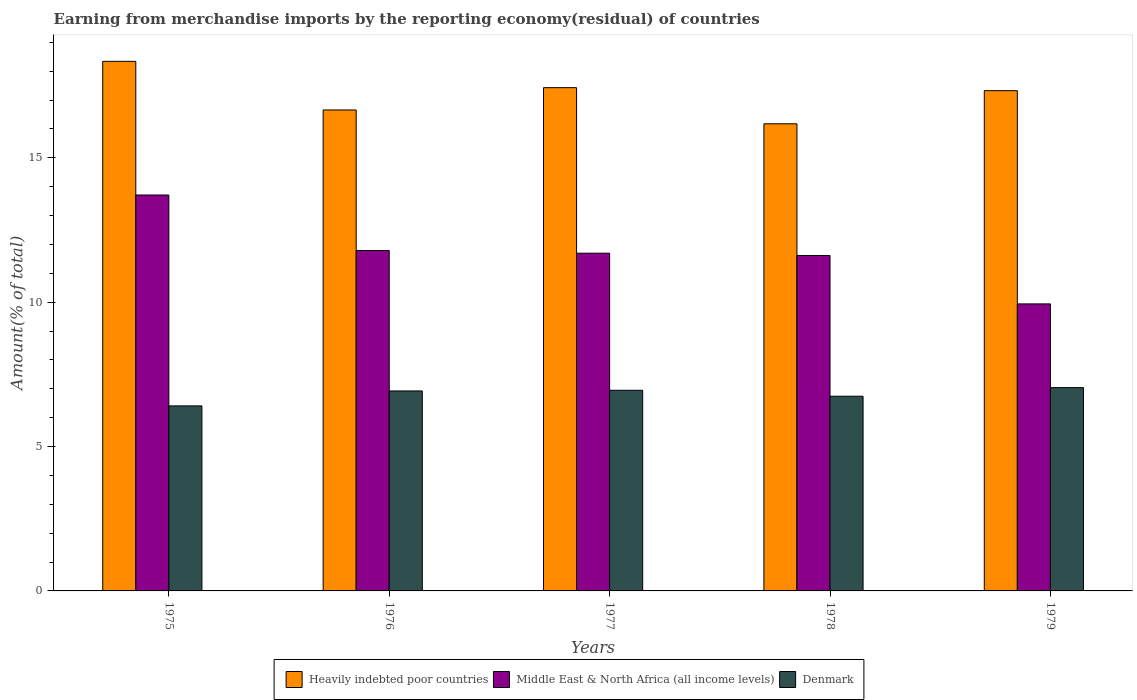How many different coloured bars are there?
Offer a very short reply. 3. How many groups of bars are there?
Ensure brevity in your answer.  5. How many bars are there on the 4th tick from the right?
Your answer should be compact. 3. What is the label of the 1st group of bars from the left?
Provide a short and direct response. 1975. What is the percentage of amount earned from merchandise imports in Middle East & North Africa (all income levels) in 1976?
Offer a very short reply. 11.79. Across all years, what is the maximum percentage of amount earned from merchandise imports in Heavily indebted poor countries?
Provide a succinct answer. 18.34. Across all years, what is the minimum percentage of amount earned from merchandise imports in Middle East & North Africa (all income levels)?
Your response must be concise. 9.94. In which year was the percentage of amount earned from merchandise imports in Heavily indebted poor countries maximum?
Ensure brevity in your answer.  1975. In which year was the percentage of amount earned from merchandise imports in Heavily indebted poor countries minimum?
Your answer should be very brief. 1978. What is the total percentage of amount earned from merchandise imports in Heavily indebted poor countries in the graph?
Ensure brevity in your answer.  85.93. What is the difference between the percentage of amount earned from merchandise imports in Middle East & North Africa (all income levels) in 1975 and that in 1977?
Offer a terse response. 2.02. What is the difference between the percentage of amount earned from merchandise imports in Heavily indebted poor countries in 1977 and the percentage of amount earned from merchandise imports in Middle East & North Africa (all income levels) in 1976?
Offer a terse response. 5.64. What is the average percentage of amount earned from merchandise imports in Middle East & North Africa (all income levels) per year?
Offer a very short reply. 11.75. In the year 1979, what is the difference between the percentage of amount earned from merchandise imports in Middle East & North Africa (all income levels) and percentage of amount earned from merchandise imports in Denmark?
Provide a succinct answer. 2.9. In how many years, is the percentage of amount earned from merchandise imports in Heavily indebted poor countries greater than 7 %?
Ensure brevity in your answer.  5. What is the ratio of the percentage of amount earned from merchandise imports in Denmark in 1975 to that in 1977?
Your answer should be very brief. 0.92. What is the difference between the highest and the second highest percentage of amount earned from merchandise imports in Heavily indebted poor countries?
Offer a very short reply. 0.91. What is the difference between the highest and the lowest percentage of amount earned from merchandise imports in Middle East & North Africa (all income levels)?
Ensure brevity in your answer.  3.77. Is the sum of the percentage of amount earned from merchandise imports in Denmark in 1977 and 1978 greater than the maximum percentage of amount earned from merchandise imports in Heavily indebted poor countries across all years?
Provide a succinct answer. No. What does the 1st bar from the left in 1979 represents?
Provide a succinct answer. Heavily indebted poor countries. What does the 3rd bar from the right in 1976 represents?
Make the answer very short. Heavily indebted poor countries. How many years are there in the graph?
Provide a short and direct response. 5. Where does the legend appear in the graph?
Your answer should be compact. Bottom center. What is the title of the graph?
Offer a terse response. Earning from merchandise imports by the reporting economy(residual) of countries. Does "Lao PDR" appear as one of the legend labels in the graph?
Your answer should be very brief. No. What is the label or title of the X-axis?
Provide a succinct answer. Years. What is the label or title of the Y-axis?
Keep it short and to the point. Amount(% of total). What is the Amount(% of total) in Heavily indebted poor countries in 1975?
Give a very brief answer. 18.34. What is the Amount(% of total) in Middle East & North Africa (all income levels) in 1975?
Keep it short and to the point. 13.71. What is the Amount(% of total) of Denmark in 1975?
Your answer should be very brief. 6.41. What is the Amount(% of total) of Heavily indebted poor countries in 1976?
Your response must be concise. 16.66. What is the Amount(% of total) in Middle East & North Africa (all income levels) in 1976?
Give a very brief answer. 11.79. What is the Amount(% of total) in Denmark in 1976?
Provide a short and direct response. 6.93. What is the Amount(% of total) of Heavily indebted poor countries in 1977?
Provide a succinct answer. 17.43. What is the Amount(% of total) of Middle East & North Africa (all income levels) in 1977?
Offer a very short reply. 11.7. What is the Amount(% of total) in Denmark in 1977?
Your response must be concise. 6.95. What is the Amount(% of total) of Heavily indebted poor countries in 1978?
Your answer should be very brief. 16.18. What is the Amount(% of total) of Middle East & North Africa (all income levels) in 1978?
Your response must be concise. 11.62. What is the Amount(% of total) in Denmark in 1978?
Provide a short and direct response. 6.74. What is the Amount(% of total) in Heavily indebted poor countries in 1979?
Provide a short and direct response. 17.33. What is the Amount(% of total) in Middle East & North Africa (all income levels) in 1979?
Give a very brief answer. 9.94. What is the Amount(% of total) in Denmark in 1979?
Provide a succinct answer. 7.04. Across all years, what is the maximum Amount(% of total) of Heavily indebted poor countries?
Your response must be concise. 18.34. Across all years, what is the maximum Amount(% of total) in Middle East & North Africa (all income levels)?
Provide a succinct answer. 13.71. Across all years, what is the maximum Amount(% of total) of Denmark?
Your response must be concise. 7.04. Across all years, what is the minimum Amount(% of total) in Heavily indebted poor countries?
Provide a succinct answer. 16.18. Across all years, what is the minimum Amount(% of total) in Middle East & North Africa (all income levels)?
Ensure brevity in your answer.  9.94. Across all years, what is the minimum Amount(% of total) in Denmark?
Provide a succinct answer. 6.41. What is the total Amount(% of total) in Heavily indebted poor countries in the graph?
Ensure brevity in your answer.  85.93. What is the total Amount(% of total) of Middle East & North Africa (all income levels) in the graph?
Your answer should be compact. 58.76. What is the total Amount(% of total) in Denmark in the graph?
Provide a short and direct response. 34.07. What is the difference between the Amount(% of total) of Heavily indebted poor countries in 1975 and that in 1976?
Your response must be concise. 1.68. What is the difference between the Amount(% of total) in Middle East & North Africa (all income levels) in 1975 and that in 1976?
Give a very brief answer. 1.92. What is the difference between the Amount(% of total) in Denmark in 1975 and that in 1976?
Ensure brevity in your answer.  -0.52. What is the difference between the Amount(% of total) in Heavily indebted poor countries in 1975 and that in 1977?
Offer a very short reply. 0.91. What is the difference between the Amount(% of total) of Middle East & North Africa (all income levels) in 1975 and that in 1977?
Make the answer very short. 2.02. What is the difference between the Amount(% of total) of Denmark in 1975 and that in 1977?
Give a very brief answer. -0.54. What is the difference between the Amount(% of total) in Heavily indebted poor countries in 1975 and that in 1978?
Provide a succinct answer. 2.16. What is the difference between the Amount(% of total) in Middle East & North Africa (all income levels) in 1975 and that in 1978?
Your answer should be compact. 2.09. What is the difference between the Amount(% of total) in Denmark in 1975 and that in 1978?
Make the answer very short. -0.33. What is the difference between the Amount(% of total) of Heavily indebted poor countries in 1975 and that in 1979?
Offer a very short reply. 1.02. What is the difference between the Amount(% of total) of Middle East & North Africa (all income levels) in 1975 and that in 1979?
Your answer should be very brief. 3.77. What is the difference between the Amount(% of total) in Denmark in 1975 and that in 1979?
Offer a very short reply. -0.63. What is the difference between the Amount(% of total) in Heavily indebted poor countries in 1976 and that in 1977?
Provide a short and direct response. -0.77. What is the difference between the Amount(% of total) of Middle East & North Africa (all income levels) in 1976 and that in 1977?
Your response must be concise. 0.09. What is the difference between the Amount(% of total) in Denmark in 1976 and that in 1977?
Ensure brevity in your answer.  -0.02. What is the difference between the Amount(% of total) of Heavily indebted poor countries in 1976 and that in 1978?
Offer a very short reply. 0.48. What is the difference between the Amount(% of total) in Middle East & North Africa (all income levels) in 1976 and that in 1978?
Keep it short and to the point. 0.17. What is the difference between the Amount(% of total) in Denmark in 1976 and that in 1978?
Make the answer very short. 0.18. What is the difference between the Amount(% of total) of Heavily indebted poor countries in 1976 and that in 1979?
Provide a succinct answer. -0.67. What is the difference between the Amount(% of total) of Middle East & North Africa (all income levels) in 1976 and that in 1979?
Provide a succinct answer. 1.85. What is the difference between the Amount(% of total) in Denmark in 1976 and that in 1979?
Your answer should be very brief. -0.12. What is the difference between the Amount(% of total) in Heavily indebted poor countries in 1977 and that in 1978?
Ensure brevity in your answer.  1.25. What is the difference between the Amount(% of total) in Middle East & North Africa (all income levels) in 1977 and that in 1978?
Your response must be concise. 0.08. What is the difference between the Amount(% of total) of Denmark in 1977 and that in 1978?
Provide a succinct answer. 0.21. What is the difference between the Amount(% of total) of Heavily indebted poor countries in 1977 and that in 1979?
Make the answer very short. 0.1. What is the difference between the Amount(% of total) in Middle East & North Africa (all income levels) in 1977 and that in 1979?
Offer a terse response. 1.76. What is the difference between the Amount(% of total) in Denmark in 1977 and that in 1979?
Offer a terse response. -0.09. What is the difference between the Amount(% of total) of Heavily indebted poor countries in 1978 and that in 1979?
Keep it short and to the point. -1.15. What is the difference between the Amount(% of total) in Middle East & North Africa (all income levels) in 1978 and that in 1979?
Give a very brief answer. 1.68. What is the difference between the Amount(% of total) of Denmark in 1978 and that in 1979?
Provide a succinct answer. -0.3. What is the difference between the Amount(% of total) of Heavily indebted poor countries in 1975 and the Amount(% of total) of Middle East & North Africa (all income levels) in 1976?
Your response must be concise. 6.55. What is the difference between the Amount(% of total) in Heavily indebted poor countries in 1975 and the Amount(% of total) in Denmark in 1976?
Offer a terse response. 11.42. What is the difference between the Amount(% of total) of Middle East & North Africa (all income levels) in 1975 and the Amount(% of total) of Denmark in 1976?
Ensure brevity in your answer.  6.79. What is the difference between the Amount(% of total) in Heavily indebted poor countries in 1975 and the Amount(% of total) in Middle East & North Africa (all income levels) in 1977?
Ensure brevity in your answer.  6.64. What is the difference between the Amount(% of total) of Heavily indebted poor countries in 1975 and the Amount(% of total) of Denmark in 1977?
Ensure brevity in your answer.  11.39. What is the difference between the Amount(% of total) of Middle East & North Africa (all income levels) in 1975 and the Amount(% of total) of Denmark in 1977?
Provide a succinct answer. 6.76. What is the difference between the Amount(% of total) in Heavily indebted poor countries in 1975 and the Amount(% of total) in Middle East & North Africa (all income levels) in 1978?
Ensure brevity in your answer.  6.72. What is the difference between the Amount(% of total) of Heavily indebted poor countries in 1975 and the Amount(% of total) of Denmark in 1978?
Provide a short and direct response. 11.6. What is the difference between the Amount(% of total) of Middle East & North Africa (all income levels) in 1975 and the Amount(% of total) of Denmark in 1978?
Make the answer very short. 6.97. What is the difference between the Amount(% of total) of Heavily indebted poor countries in 1975 and the Amount(% of total) of Middle East & North Africa (all income levels) in 1979?
Offer a terse response. 8.4. What is the difference between the Amount(% of total) of Heavily indebted poor countries in 1975 and the Amount(% of total) of Denmark in 1979?
Ensure brevity in your answer.  11.3. What is the difference between the Amount(% of total) of Middle East & North Africa (all income levels) in 1975 and the Amount(% of total) of Denmark in 1979?
Keep it short and to the point. 6.67. What is the difference between the Amount(% of total) of Heavily indebted poor countries in 1976 and the Amount(% of total) of Middle East & North Africa (all income levels) in 1977?
Make the answer very short. 4.96. What is the difference between the Amount(% of total) of Heavily indebted poor countries in 1976 and the Amount(% of total) of Denmark in 1977?
Keep it short and to the point. 9.71. What is the difference between the Amount(% of total) in Middle East & North Africa (all income levels) in 1976 and the Amount(% of total) in Denmark in 1977?
Provide a succinct answer. 4.84. What is the difference between the Amount(% of total) of Heavily indebted poor countries in 1976 and the Amount(% of total) of Middle East & North Africa (all income levels) in 1978?
Give a very brief answer. 5.04. What is the difference between the Amount(% of total) of Heavily indebted poor countries in 1976 and the Amount(% of total) of Denmark in 1978?
Provide a succinct answer. 9.91. What is the difference between the Amount(% of total) in Middle East & North Africa (all income levels) in 1976 and the Amount(% of total) in Denmark in 1978?
Your answer should be compact. 5.05. What is the difference between the Amount(% of total) of Heavily indebted poor countries in 1976 and the Amount(% of total) of Middle East & North Africa (all income levels) in 1979?
Keep it short and to the point. 6.72. What is the difference between the Amount(% of total) of Heavily indebted poor countries in 1976 and the Amount(% of total) of Denmark in 1979?
Offer a very short reply. 9.62. What is the difference between the Amount(% of total) in Middle East & North Africa (all income levels) in 1976 and the Amount(% of total) in Denmark in 1979?
Your answer should be very brief. 4.75. What is the difference between the Amount(% of total) in Heavily indebted poor countries in 1977 and the Amount(% of total) in Middle East & North Africa (all income levels) in 1978?
Your answer should be very brief. 5.81. What is the difference between the Amount(% of total) in Heavily indebted poor countries in 1977 and the Amount(% of total) in Denmark in 1978?
Provide a succinct answer. 10.69. What is the difference between the Amount(% of total) in Middle East & North Africa (all income levels) in 1977 and the Amount(% of total) in Denmark in 1978?
Your answer should be very brief. 4.95. What is the difference between the Amount(% of total) in Heavily indebted poor countries in 1977 and the Amount(% of total) in Middle East & North Africa (all income levels) in 1979?
Your answer should be very brief. 7.49. What is the difference between the Amount(% of total) in Heavily indebted poor countries in 1977 and the Amount(% of total) in Denmark in 1979?
Give a very brief answer. 10.39. What is the difference between the Amount(% of total) in Middle East & North Africa (all income levels) in 1977 and the Amount(% of total) in Denmark in 1979?
Make the answer very short. 4.66. What is the difference between the Amount(% of total) in Heavily indebted poor countries in 1978 and the Amount(% of total) in Middle East & North Africa (all income levels) in 1979?
Give a very brief answer. 6.24. What is the difference between the Amount(% of total) of Heavily indebted poor countries in 1978 and the Amount(% of total) of Denmark in 1979?
Give a very brief answer. 9.14. What is the difference between the Amount(% of total) of Middle East & North Africa (all income levels) in 1978 and the Amount(% of total) of Denmark in 1979?
Give a very brief answer. 4.58. What is the average Amount(% of total) in Heavily indebted poor countries per year?
Make the answer very short. 17.19. What is the average Amount(% of total) in Middle East & North Africa (all income levels) per year?
Provide a succinct answer. 11.75. What is the average Amount(% of total) of Denmark per year?
Make the answer very short. 6.81. In the year 1975, what is the difference between the Amount(% of total) in Heavily indebted poor countries and Amount(% of total) in Middle East & North Africa (all income levels)?
Give a very brief answer. 4.63. In the year 1975, what is the difference between the Amount(% of total) of Heavily indebted poor countries and Amount(% of total) of Denmark?
Keep it short and to the point. 11.93. In the year 1975, what is the difference between the Amount(% of total) in Middle East & North Africa (all income levels) and Amount(% of total) in Denmark?
Your answer should be compact. 7.3. In the year 1976, what is the difference between the Amount(% of total) of Heavily indebted poor countries and Amount(% of total) of Middle East & North Africa (all income levels)?
Offer a terse response. 4.87. In the year 1976, what is the difference between the Amount(% of total) of Heavily indebted poor countries and Amount(% of total) of Denmark?
Make the answer very short. 9.73. In the year 1976, what is the difference between the Amount(% of total) in Middle East & North Africa (all income levels) and Amount(% of total) in Denmark?
Keep it short and to the point. 4.86. In the year 1977, what is the difference between the Amount(% of total) of Heavily indebted poor countries and Amount(% of total) of Middle East & North Africa (all income levels)?
Your answer should be very brief. 5.73. In the year 1977, what is the difference between the Amount(% of total) in Heavily indebted poor countries and Amount(% of total) in Denmark?
Make the answer very short. 10.48. In the year 1977, what is the difference between the Amount(% of total) in Middle East & North Africa (all income levels) and Amount(% of total) in Denmark?
Offer a very short reply. 4.75. In the year 1978, what is the difference between the Amount(% of total) of Heavily indebted poor countries and Amount(% of total) of Middle East & North Africa (all income levels)?
Offer a very short reply. 4.56. In the year 1978, what is the difference between the Amount(% of total) in Heavily indebted poor countries and Amount(% of total) in Denmark?
Ensure brevity in your answer.  9.44. In the year 1978, what is the difference between the Amount(% of total) in Middle East & North Africa (all income levels) and Amount(% of total) in Denmark?
Your answer should be very brief. 4.87. In the year 1979, what is the difference between the Amount(% of total) in Heavily indebted poor countries and Amount(% of total) in Middle East & North Africa (all income levels)?
Your answer should be compact. 7.38. In the year 1979, what is the difference between the Amount(% of total) in Heavily indebted poor countries and Amount(% of total) in Denmark?
Your response must be concise. 10.28. In the year 1979, what is the difference between the Amount(% of total) in Middle East & North Africa (all income levels) and Amount(% of total) in Denmark?
Offer a very short reply. 2.9. What is the ratio of the Amount(% of total) in Heavily indebted poor countries in 1975 to that in 1976?
Ensure brevity in your answer.  1.1. What is the ratio of the Amount(% of total) of Middle East & North Africa (all income levels) in 1975 to that in 1976?
Give a very brief answer. 1.16. What is the ratio of the Amount(% of total) of Denmark in 1975 to that in 1976?
Offer a very short reply. 0.93. What is the ratio of the Amount(% of total) in Heavily indebted poor countries in 1975 to that in 1977?
Provide a succinct answer. 1.05. What is the ratio of the Amount(% of total) of Middle East & North Africa (all income levels) in 1975 to that in 1977?
Provide a short and direct response. 1.17. What is the ratio of the Amount(% of total) in Denmark in 1975 to that in 1977?
Ensure brevity in your answer.  0.92. What is the ratio of the Amount(% of total) in Heavily indebted poor countries in 1975 to that in 1978?
Give a very brief answer. 1.13. What is the ratio of the Amount(% of total) in Middle East & North Africa (all income levels) in 1975 to that in 1978?
Provide a short and direct response. 1.18. What is the ratio of the Amount(% of total) of Denmark in 1975 to that in 1978?
Your answer should be very brief. 0.95. What is the ratio of the Amount(% of total) in Heavily indebted poor countries in 1975 to that in 1979?
Make the answer very short. 1.06. What is the ratio of the Amount(% of total) of Middle East & North Africa (all income levels) in 1975 to that in 1979?
Offer a very short reply. 1.38. What is the ratio of the Amount(% of total) of Denmark in 1975 to that in 1979?
Offer a terse response. 0.91. What is the ratio of the Amount(% of total) in Heavily indebted poor countries in 1976 to that in 1977?
Your answer should be very brief. 0.96. What is the ratio of the Amount(% of total) of Heavily indebted poor countries in 1976 to that in 1978?
Your answer should be compact. 1.03. What is the ratio of the Amount(% of total) of Middle East & North Africa (all income levels) in 1976 to that in 1978?
Make the answer very short. 1.01. What is the ratio of the Amount(% of total) of Denmark in 1976 to that in 1978?
Give a very brief answer. 1.03. What is the ratio of the Amount(% of total) of Heavily indebted poor countries in 1976 to that in 1979?
Give a very brief answer. 0.96. What is the ratio of the Amount(% of total) in Middle East & North Africa (all income levels) in 1976 to that in 1979?
Your answer should be compact. 1.19. What is the ratio of the Amount(% of total) in Denmark in 1976 to that in 1979?
Provide a short and direct response. 0.98. What is the ratio of the Amount(% of total) of Heavily indebted poor countries in 1977 to that in 1978?
Keep it short and to the point. 1.08. What is the ratio of the Amount(% of total) of Middle East & North Africa (all income levels) in 1977 to that in 1978?
Your answer should be compact. 1.01. What is the ratio of the Amount(% of total) of Denmark in 1977 to that in 1978?
Make the answer very short. 1.03. What is the ratio of the Amount(% of total) in Middle East & North Africa (all income levels) in 1977 to that in 1979?
Give a very brief answer. 1.18. What is the ratio of the Amount(% of total) in Heavily indebted poor countries in 1978 to that in 1979?
Provide a succinct answer. 0.93. What is the ratio of the Amount(% of total) of Middle East & North Africa (all income levels) in 1978 to that in 1979?
Make the answer very short. 1.17. What is the ratio of the Amount(% of total) of Denmark in 1978 to that in 1979?
Make the answer very short. 0.96. What is the difference between the highest and the second highest Amount(% of total) of Heavily indebted poor countries?
Offer a terse response. 0.91. What is the difference between the highest and the second highest Amount(% of total) of Middle East & North Africa (all income levels)?
Offer a terse response. 1.92. What is the difference between the highest and the second highest Amount(% of total) in Denmark?
Provide a short and direct response. 0.09. What is the difference between the highest and the lowest Amount(% of total) of Heavily indebted poor countries?
Your answer should be very brief. 2.16. What is the difference between the highest and the lowest Amount(% of total) in Middle East & North Africa (all income levels)?
Offer a very short reply. 3.77. What is the difference between the highest and the lowest Amount(% of total) of Denmark?
Your answer should be compact. 0.63. 